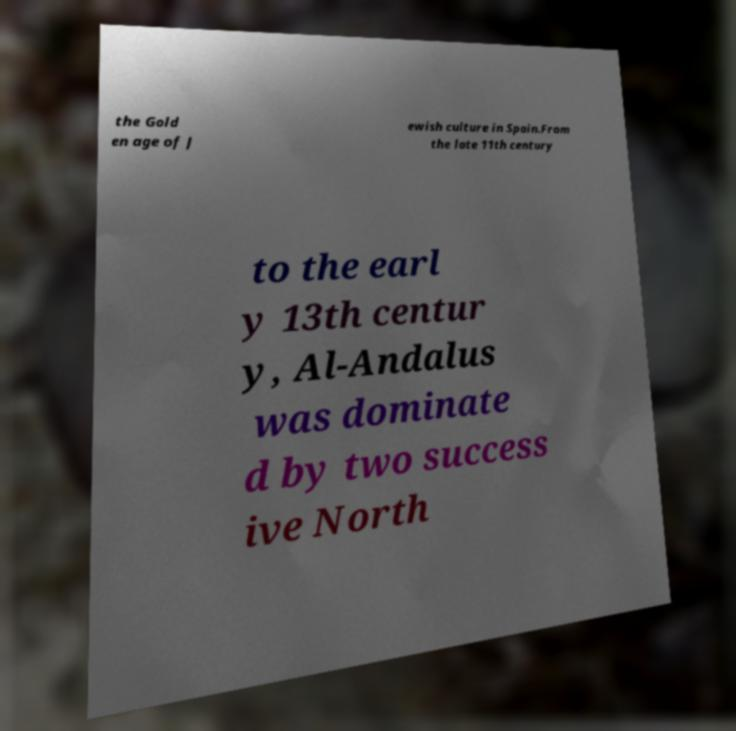Please identify and transcribe the text found in this image. the Gold en age of J ewish culture in Spain.From the late 11th century to the earl y 13th centur y, Al-Andalus was dominate d by two success ive North 